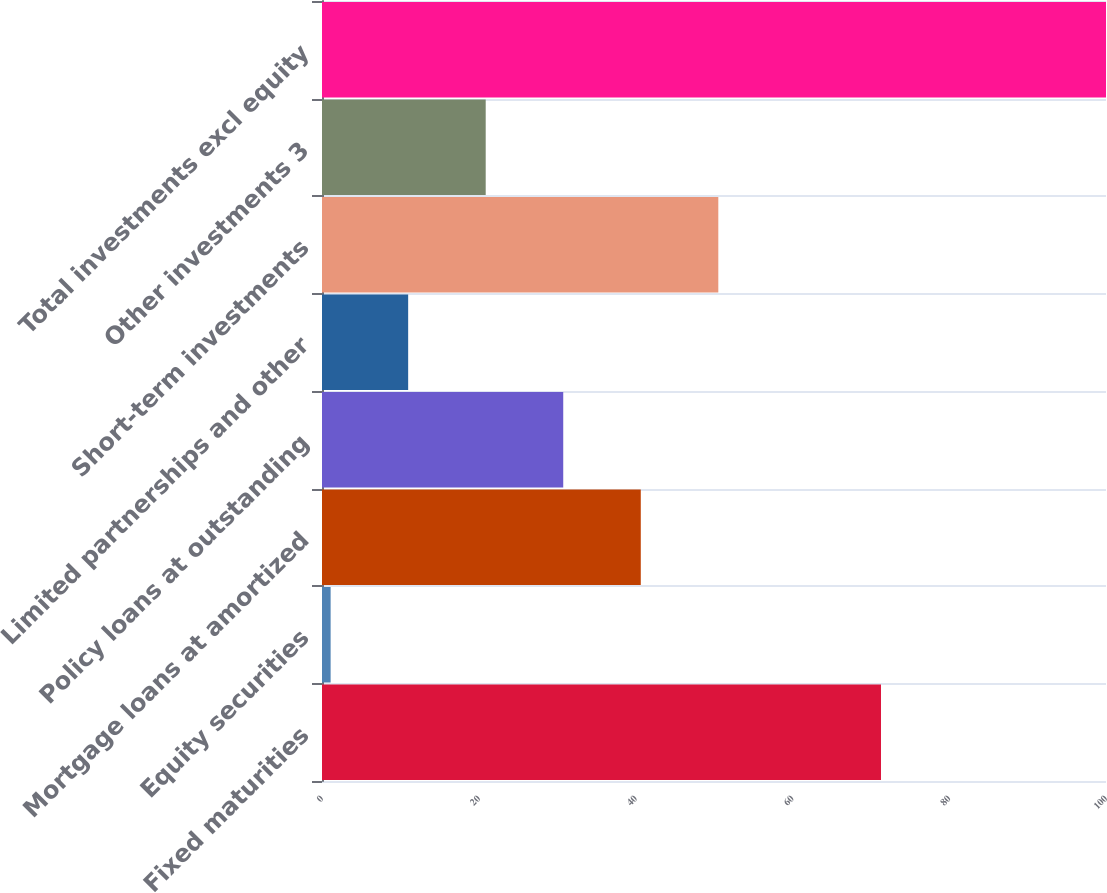Convert chart to OTSL. <chart><loc_0><loc_0><loc_500><loc_500><bar_chart><fcel>Fixed maturities<fcel>Equity securities<fcel>Mortgage loans at amortized<fcel>Policy loans at outstanding<fcel>Limited partnerships and other<fcel>Short-term investments<fcel>Other investments 3<fcel>Total investments excl equity<nl><fcel>71.3<fcel>1.1<fcel>40.66<fcel>30.77<fcel>10.99<fcel>50.55<fcel>20.88<fcel>100<nl></chart> 